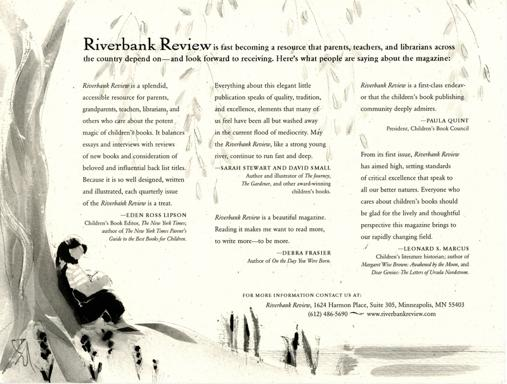What is the Riverbank Review about?
 The Riverbank Review is a magazine that focuses on children's books. It provides reviews of new books, essays, interviews with authors, and considerations of beloved and influential back titles. It is a valuable resource for parents, grandparents, teachers, librarians, and others who care about the potential impact of children's literature. What do people appreciate about the Riverbank Review? People appreciate the Riverbank Review for being a splendid and accessible resource that offers high-quality content related to children's book publishing. Its elegant design, deep insights, and critical excellence make it a valuable resource for those who care about children's books. 